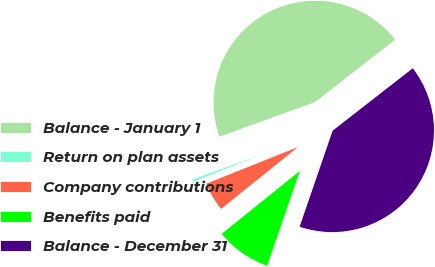Convert chart. <chart><loc_0><loc_0><loc_500><loc_500><pie_chart><fcel>Balance - January 1<fcel>Return on plan assets<fcel>Company contributions<fcel>Benefits paid<fcel>Balance - December 31<nl><fcel>45.01%<fcel>0.52%<fcel>4.73%<fcel>8.94%<fcel>40.8%<nl></chart> 